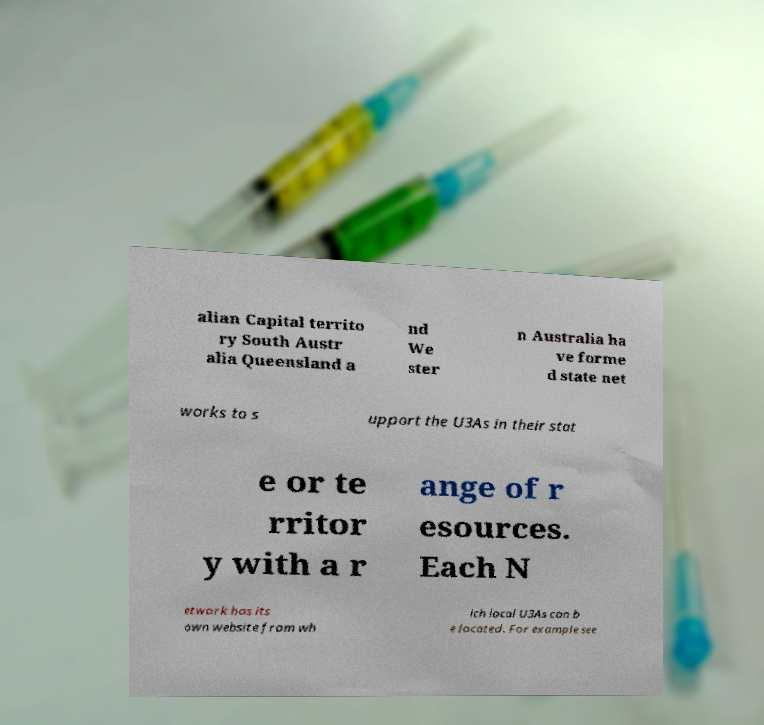I need the written content from this picture converted into text. Can you do that? alian Capital territo ry South Austr alia Queensland a nd We ster n Australia ha ve forme d state net works to s upport the U3As in their stat e or te rritor y with a r ange of r esources. Each N etwork has its own website from wh ich local U3As can b e located. For example see 